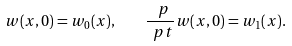Convert formula to latex. <formula><loc_0><loc_0><loc_500><loc_500>w ( x , 0 ) = w _ { 0 } ( x ) , \quad \frac { \ p } { \ p t } w ( x , 0 ) = w _ { 1 } ( x ) .</formula> 